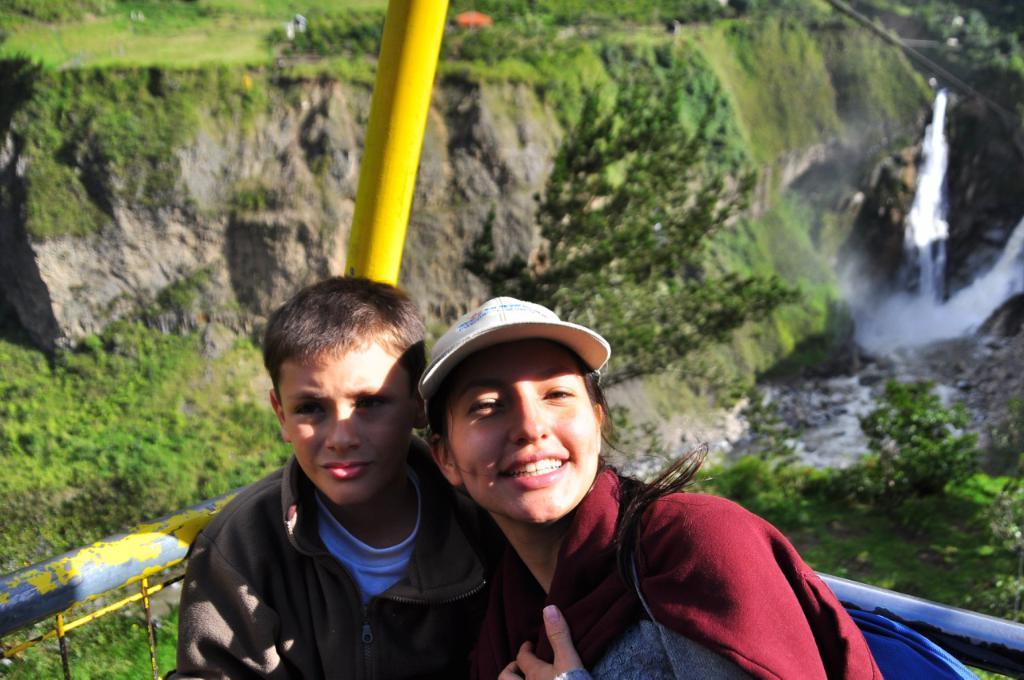Describe this image in one or two sentences. In this image in the front there are persons standing and smiling. In the center there are rods. In the background there is water and there are plants and there's grass on the ground and there are trees. 